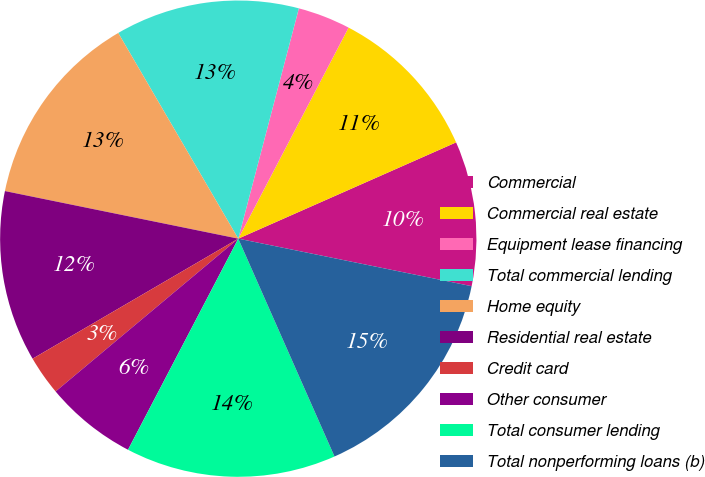Convert chart. <chart><loc_0><loc_0><loc_500><loc_500><pie_chart><fcel>Commercial<fcel>Commercial real estate<fcel>Equipment lease financing<fcel>Total commercial lending<fcel>Home equity<fcel>Residential real estate<fcel>Credit card<fcel>Other consumer<fcel>Total consumer lending<fcel>Total nonperforming loans (b)<nl><fcel>9.82%<fcel>10.71%<fcel>3.57%<fcel>12.5%<fcel>13.39%<fcel>11.61%<fcel>2.68%<fcel>6.25%<fcel>14.28%<fcel>15.18%<nl></chart> 